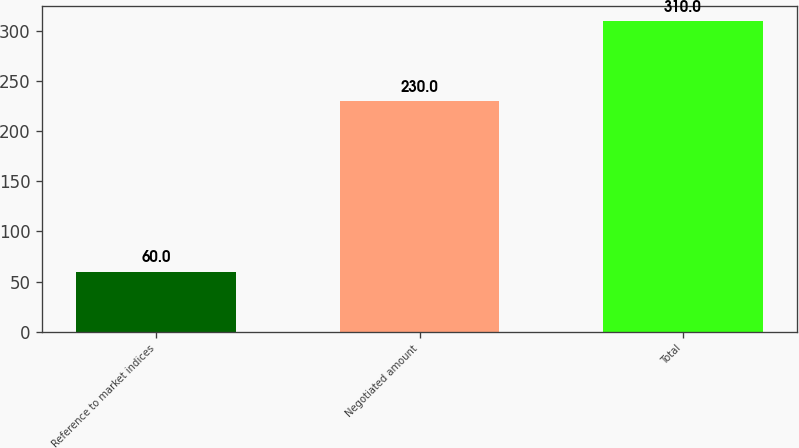<chart> <loc_0><loc_0><loc_500><loc_500><bar_chart><fcel>Reference to market indices<fcel>Negotiated amount<fcel>Total<nl><fcel>60<fcel>230<fcel>310<nl></chart> 